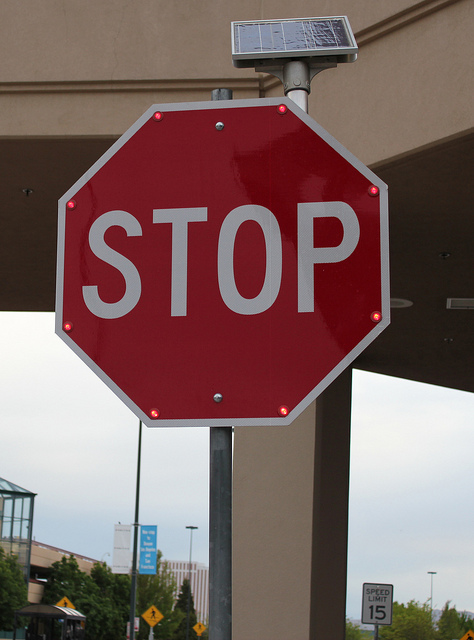Extract all visible text content from this image. STOP 15 SPEED 